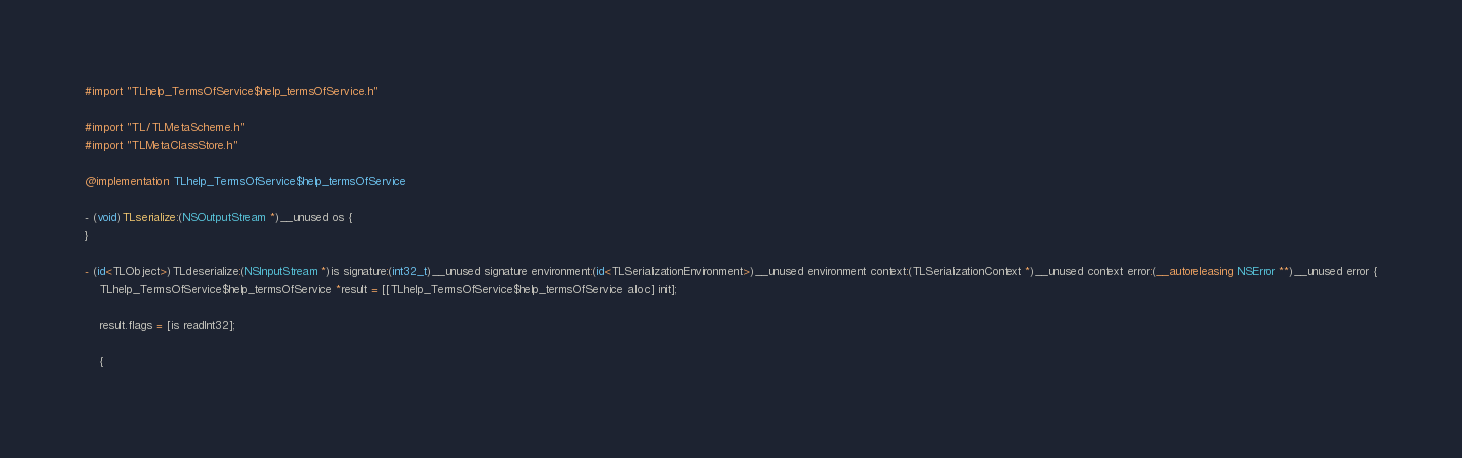<code> <loc_0><loc_0><loc_500><loc_500><_ObjectiveC_>#import "TLhelp_TermsOfService$help_termsOfService.h"

#import "TL/TLMetaScheme.h"
#import "TLMetaClassStore.h"

@implementation TLhelp_TermsOfService$help_termsOfService

- (void)TLserialize:(NSOutputStream *)__unused os {
}

- (id<TLObject>)TLdeserialize:(NSInputStream *)is signature:(int32_t)__unused signature environment:(id<TLSerializationEnvironment>)__unused environment context:(TLSerializationContext *)__unused context error:(__autoreleasing NSError **)__unused error {
    TLhelp_TermsOfService$help_termsOfService *result = [[TLhelp_TermsOfService$help_termsOfService alloc] init];
    
    result.flags = [is readInt32];
    
    {</code> 